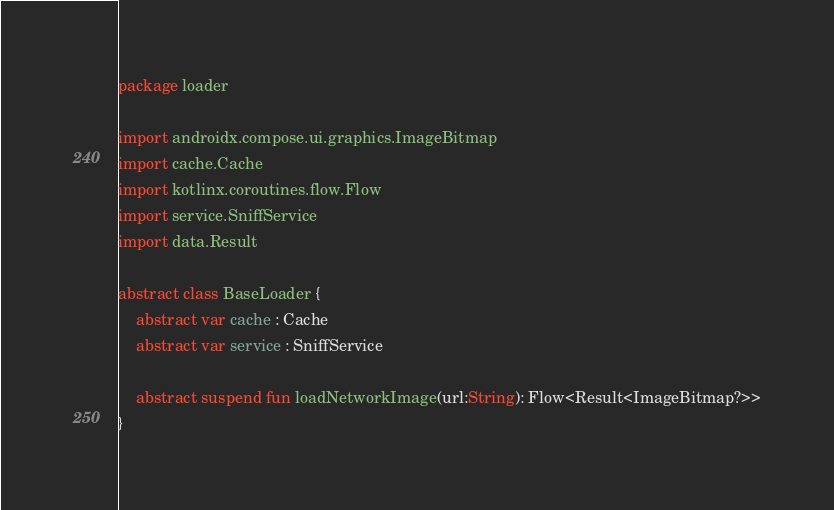<code> <loc_0><loc_0><loc_500><loc_500><_Kotlin_>package loader

import androidx.compose.ui.graphics.ImageBitmap
import cache.Cache
import kotlinx.coroutines.flow.Flow
import service.SniffService
import data.Result

abstract class BaseLoader {
    abstract var cache : Cache
    abstract var service : SniffService

    abstract suspend fun loadNetworkImage(url:String): Flow<Result<ImageBitmap?>>
}</code> 